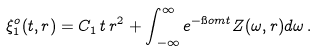Convert formula to latex. <formula><loc_0><loc_0><loc_500><loc_500>\xi ^ { o } _ { 1 } ( t , r ) = C _ { 1 } \, t \, r ^ { 2 } + \int _ { \, - \infty } ^ { \infty } e ^ { - \i o m t } Z ( \omega , r ) d \omega \, .</formula> 